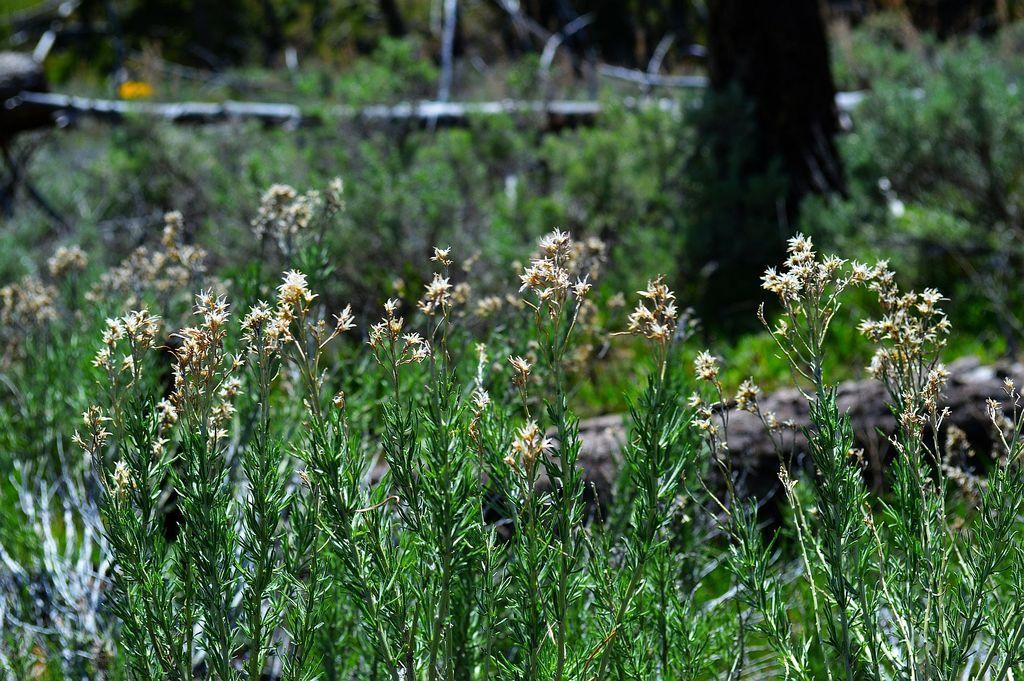Could you give a brief overview of what you see in this image? At the bottom there are few plants along with the flowers. On the right side there is a trunk behind the plants. In the background there are many plants and trunks. 